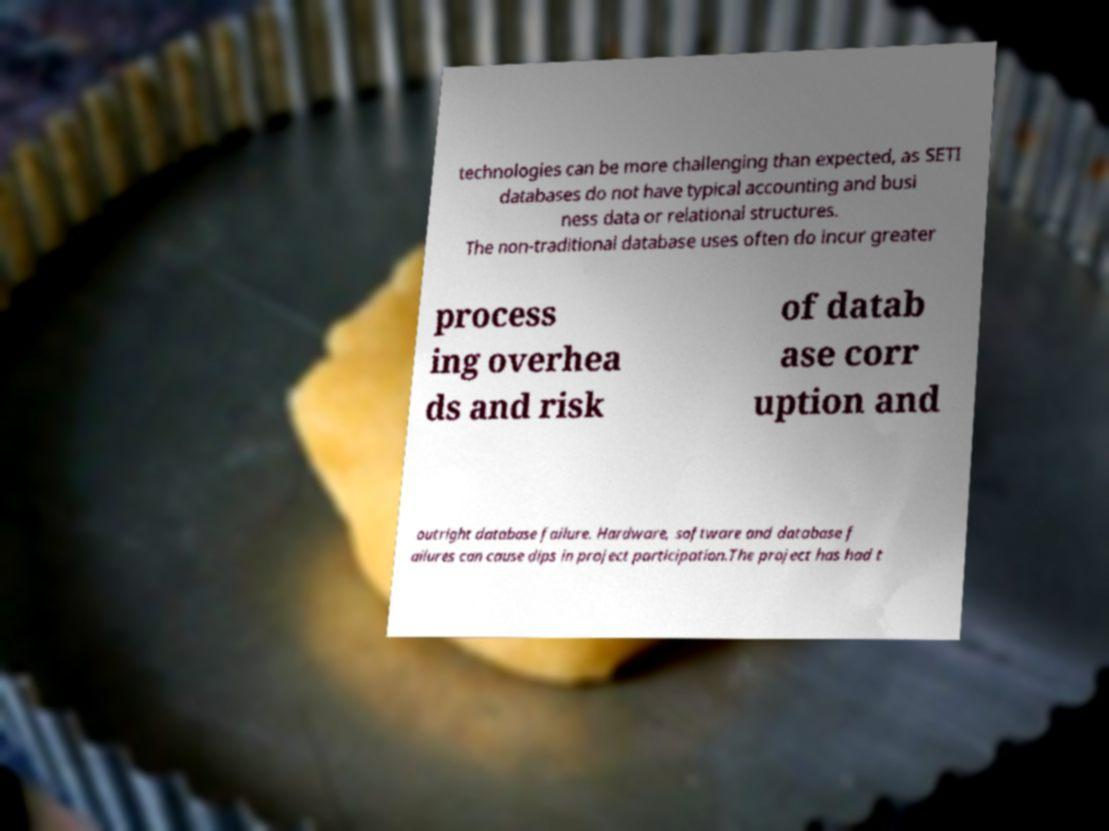Please identify and transcribe the text found in this image. technologies can be more challenging than expected, as SETI databases do not have typical accounting and busi ness data or relational structures. The non-traditional database uses often do incur greater process ing overhea ds and risk of datab ase corr uption and outright database failure. Hardware, software and database f ailures can cause dips in project participation.The project has had t 